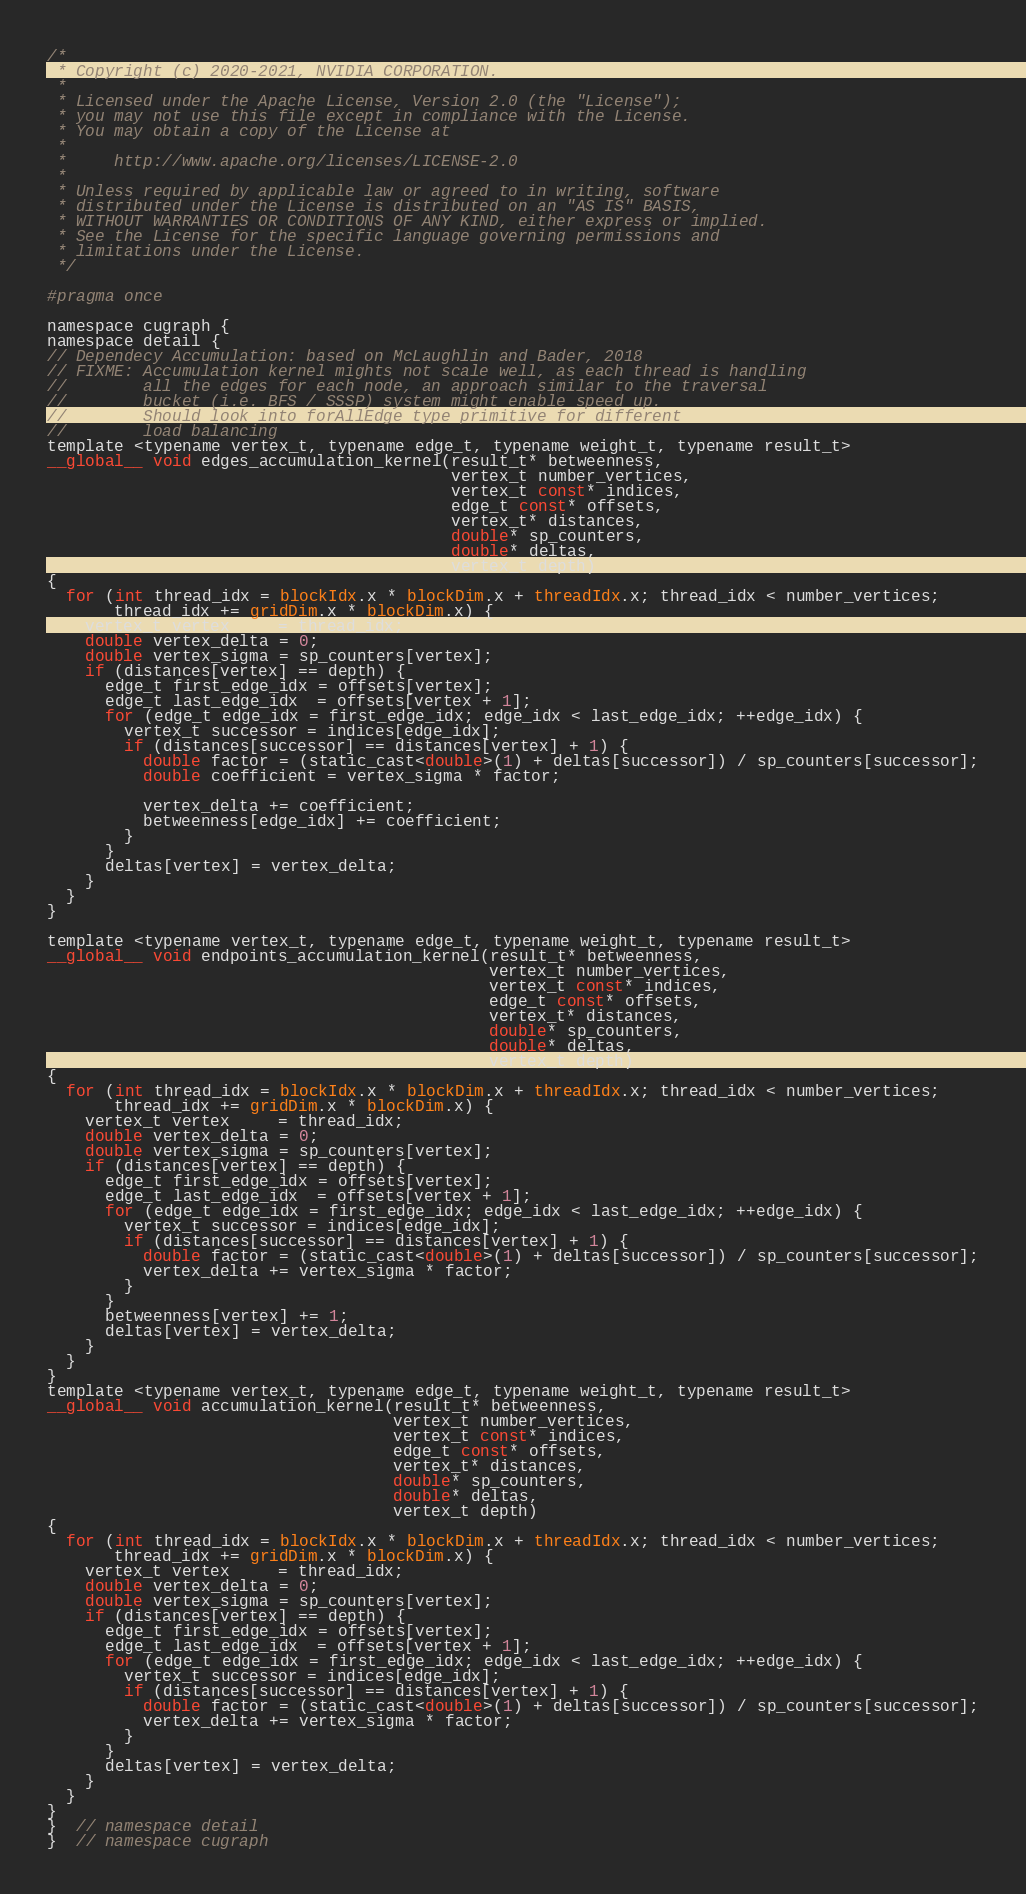<code> <loc_0><loc_0><loc_500><loc_500><_Cuda_>/*
 * Copyright (c) 2020-2021, NVIDIA CORPORATION.
 *
 * Licensed under the Apache License, Version 2.0 (the "License");
 * you may not use this file except in compliance with the License.
 * You may obtain a copy of the License at
 *
 *     http://www.apache.org/licenses/LICENSE-2.0
 *
 * Unless required by applicable law or agreed to in writing, software
 * distributed under the License is distributed on an "AS IS" BASIS,
 * WITHOUT WARRANTIES OR CONDITIONS OF ANY KIND, either express or implied.
 * See the License for the specific language governing permissions and
 * limitations under the License.
 */

#pragma once

namespace cugraph {
namespace detail {
// Dependecy Accumulation: based on McLaughlin and Bader, 2018
// FIXME: Accumulation kernel mights not scale well, as each thread is handling
//        all the edges for each node, an approach similar to the traversal
//        bucket (i.e. BFS / SSSP) system might enable speed up.
//        Should look into forAllEdge type primitive for different
//        load balancing
template <typename vertex_t, typename edge_t, typename weight_t, typename result_t>
__global__ void edges_accumulation_kernel(result_t* betweenness,
                                          vertex_t number_vertices,
                                          vertex_t const* indices,
                                          edge_t const* offsets,
                                          vertex_t* distances,
                                          double* sp_counters,
                                          double* deltas,
                                          vertex_t depth)
{
  for (int thread_idx = blockIdx.x * blockDim.x + threadIdx.x; thread_idx < number_vertices;
       thread_idx += gridDim.x * blockDim.x) {
    vertex_t vertex     = thread_idx;
    double vertex_delta = 0;
    double vertex_sigma = sp_counters[vertex];
    if (distances[vertex] == depth) {
      edge_t first_edge_idx = offsets[vertex];
      edge_t last_edge_idx  = offsets[vertex + 1];
      for (edge_t edge_idx = first_edge_idx; edge_idx < last_edge_idx; ++edge_idx) {
        vertex_t successor = indices[edge_idx];
        if (distances[successor] == distances[vertex] + 1) {
          double factor = (static_cast<double>(1) + deltas[successor]) / sp_counters[successor];
          double coefficient = vertex_sigma * factor;

          vertex_delta += coefficient;
          betweenness[edge_idx] += coefficient;
        }
      }
      deltas[vertex] = vertex_delta;
    }
  }
}

template <typename vertex_t, typename edge_t, typename weight_t, typename result_t>
__global__ void endpoints_accumulation_kernel(result_t* betweenness,
                                              vertex_t number_vertices,
                                              vertex_t const* indices,
                                              edge_t const* offsets,
                                              vertex_t* distances,
                                              double* sp_counters,
                                              double* deltas,
                                              vertex_t depth)
{
  for (int thread_idx = blockIdx.x * blockDim.x + threadIdx.x; thread_idx < number_vertices;
       thread_idx += gridDim.x * blockDim.x) {
    vertex_t vertex     = thread_idx;
    double vertex_delta = 0;
    double vertex_sigma = sp_counters[vertex];
    if (distances[vertex] == depth) {
      edge_t first_edge_idx = offsets[vertex];
      edge_t last_edge_idx  = offsets[vertex + 1];
      for (edge_t edge_idx = first_edge_idx; edge_idx < last_edge_idx; ++edge_idx) {
        vertex_t successor = indices[edge_idx];
        if (distances[successor] == distances[vertex] + 1) {
          double factor = (static_cast<double>(1) + deltas[successor]) / sp_counters[successor];
          vertex_delta += vertex_sigma * factor;
        }
      }
      betweenness[vertex] += 1;
      deltas[vertex] = vertex_delta;
    }
  }
}
template <typename vertex_t, typename edge_t, typename weight_t, typename result_t>
__global__ void accumulation_kernel(result_t* betweenness,
                                    vertex_t number_vertices,
                                    vertex_t const* indices,
                                    edge_t const* offsets,
                                    vertex_t* distances,
                                    double* sp_counters,
                                    double* deltas,
                                    vertex_t depth)
{
  for (int thread_idx = blockIdx.x * blockDim.x + threadIdx.x; thread_idx < number_vertices;
       thread_idx += gridDim.x * blockDim.x) {
    vertex_t vertex     = thread_idx;
    double vertex_delta = 0;
    double vertex_sigma = sp_counters[vertex];
    if (distances[vertex] == depth) {
      edge_t first_edge_idx = offsets[vertex];
      edge_t last_edge_idx  = offsets[vertex + 1];
      for (edge_t edge_idx = first_edge_idx; edge_idx < last_edge_idx; ++edge_idx) {
        vertex_t successor = indices[edge_idx];
        if (distances[successor] == distances[vertex] + 1) {
          double factor = (static_cast<double>(1) + deltas[successor]) / sp_counters[successor];
          vertex_delta += vertex_sigma * factor;
        }
      }
      deltas[vertex] = vertex_delta;
    }
  }
}
}  // namespace detail
}  // namespace cugraph
</code> 